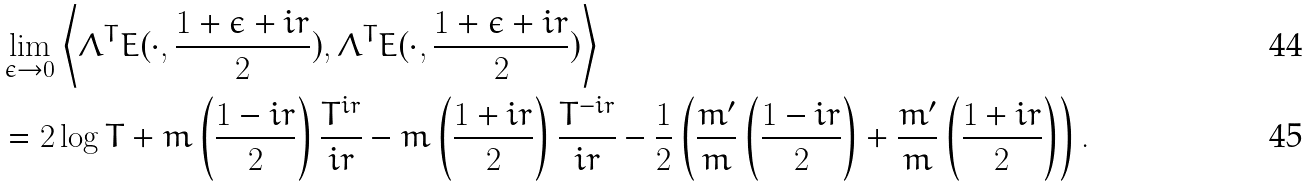<formula> <loc_0><loc_0><loc_500><loc_500>& \lim _ { \epsilon \to 0 } \left \langle \Lambda ^ { T } E ( \cdot , \frac { 1 + \epsilon + i r } { 2 } ) , \Lambda ^ { T } E ( \cdot , \frac { 1 + \epsilon + i r } { 2 } ) \right \rangle \\ & = 2 \log T + m \left ( \frac { 1 - i r } { 2 } \right ) \frac { T ^ { i r } } { i r } - m \left ( \frac { 1 + i r } { 2 } \right ) \frac { T ^ { - i r } } { i r } - \frac { 1 } { 2 } \left ( \frac { m ^ { \prime } } { m } \left ( \frac { 1 - i r } { 2 } \right ) + \frac { m ^ { \prime } } { m } \left ( \frac { 1 + i r } { 2 } \right ) \right ) .</formula> 